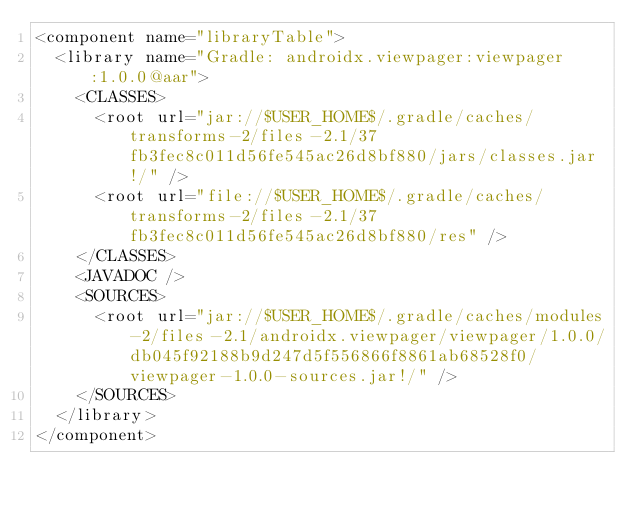Convert code to text. <code><loc_0><loc_0><loc_500><loc_500><_XML_><component name="libraryTable">
  <library name="Gradle: androidx.viewpager:viewpager:1.0.0@aar">
    <CLASSES>
      <root url="jar://$USER_HOME$/.gradle/caches/transforms-2/files-2.1/37fb3fec8c011d56fe545ac26d8bf880/jars/classes.jar!/" />
      <root url="file://$USER_HOME$/.gradle/caches/transforms-2/files-2.1/37fb3fec8c011d56fe545ac26d8bf880/res" />
    </CLASSES>
    <JAVADOC />
    <SOURCES>
      <root url="jar://$USER_HOME$/.gradle/caches/modules-2/files-2.1/androidx.viewpager/viewpager/1.0.0/db045f92188b9d247d5f556866f8861ab68528f0/viewpager-1.0.0-sources.jar!/" />
    </SOURCES>
  </library>
</component></code> 